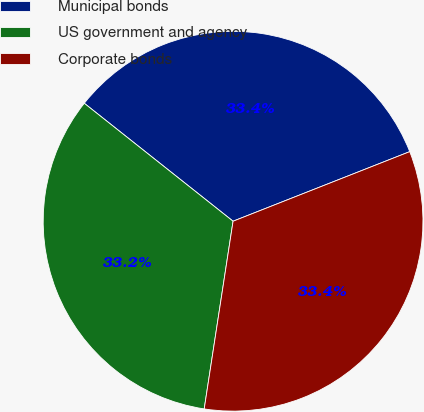<chart> <loc_0><loc_0><loc_500><loc_500><pie_chart><fcel>Municipal bonds<fcel>US government and agency<fcel>Corporate bonds<nl><fcel>33.36%<fcel>33.24%<fcel>33.4%<nl></chart> 